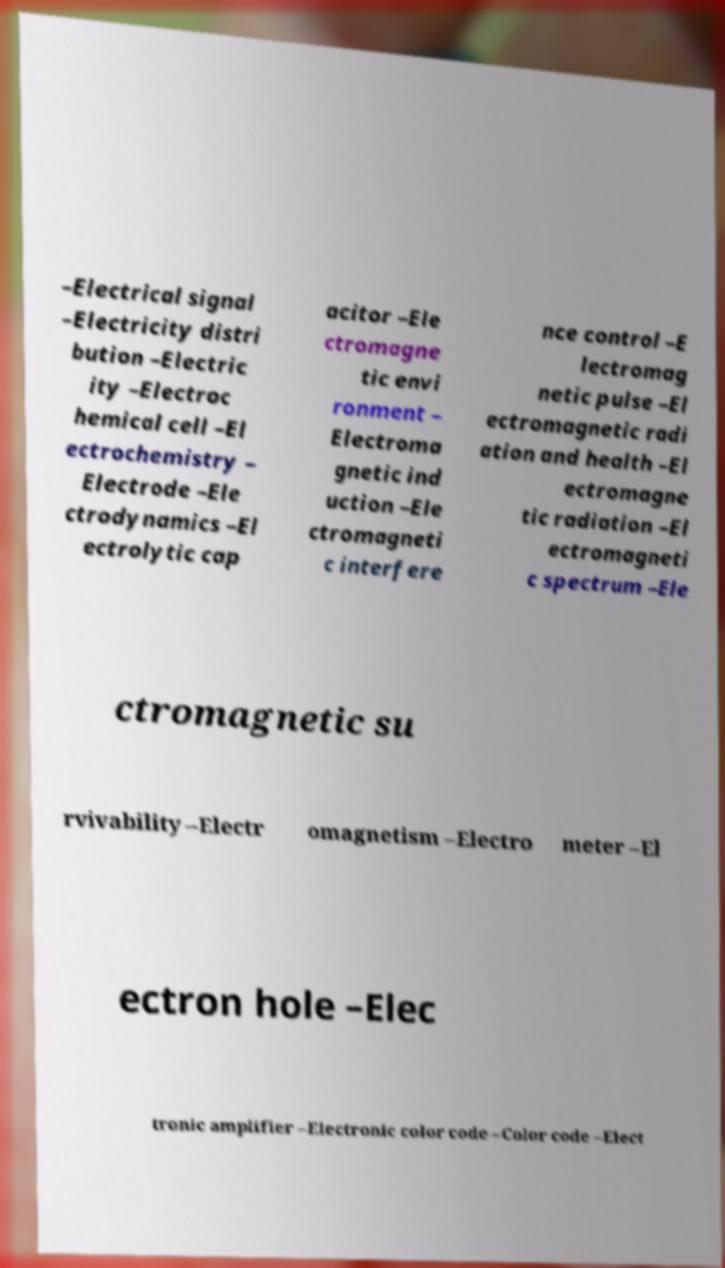Please identify and transcribe the text found in this image. –Electrical signal –Electricity distri bution –Electric ity –Electroc hemical cell –El ectrochemistry – Electrode –Ele ctrodynamics –El ectrolytic cap acitor –Ele ctromagne tic envi ronment – Electroma gnetic ind uction –Ele ctromagneti c interfere nce control –E lectromag netic pulse –El ectromagnetic radi ation and health –El ectromagne tic radiation –El ectromagneti c spectrum –Ele ctromagnetic su rvivability –Electr omagnetism –Electro meter –El ectron hole –Elec tronic amplifier –Electronic color code –Color code –Elect 